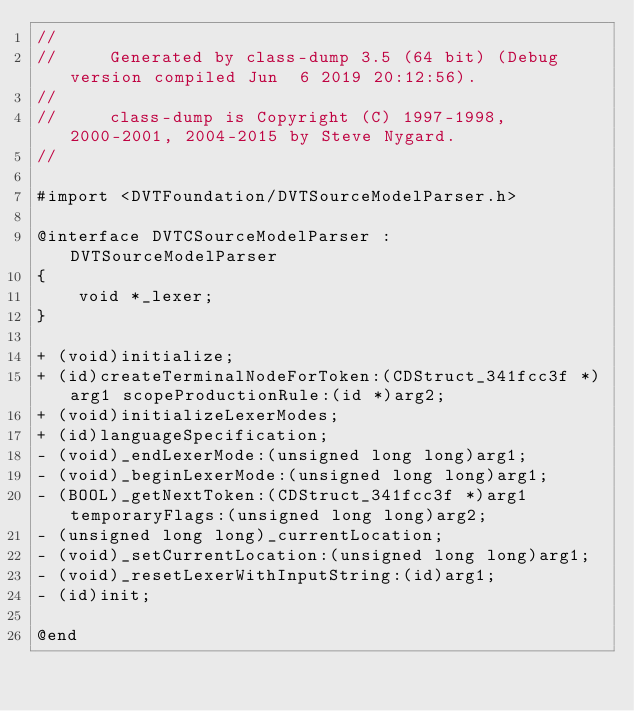Convert code to text. <code><loc_0><loc_0><loc_500><loc_500><_C_>//
//     Generated by class-dump 3.5 (64 bit) (Debug version compiled Jun  6 2019 20:12:56).
//
//     class-dump is Copyright (C) 1997-1998, 2000-2001, 2004-2015 by Steve Nygard.
//

#import <DVTFoundation/DVTSourceModelParser.h>

@interface DVTCSourceModelParser : DVTSourceModelParser
{
    void *_lexer;
}

+ (void)initialize;
+ (id)createTerminalNodeForToken:(CDStruct_341fcc3f *)arg1 scopeProductionRule:(id *)arg2;
+ (void)initializeLexerModes;
+ (id)languageSpecification;
- (void)_endLexerMode:(unsigned long long)arg1;
- (void)_beginLexerMode:(unsigned long long)arg1;
- (BOOL)_getNextToken:(CDStruct_341fcc3f *)arg1 temporaryFlags:(unsigned long long)arg2;
- (unsigned long long)_currentLocation;
- (void)_setCurrentLocation:(unsigned long long)arg1;
- (void)_resetLexerWithInputString:(id)arg1;
- (id)init;

@end

</code> 